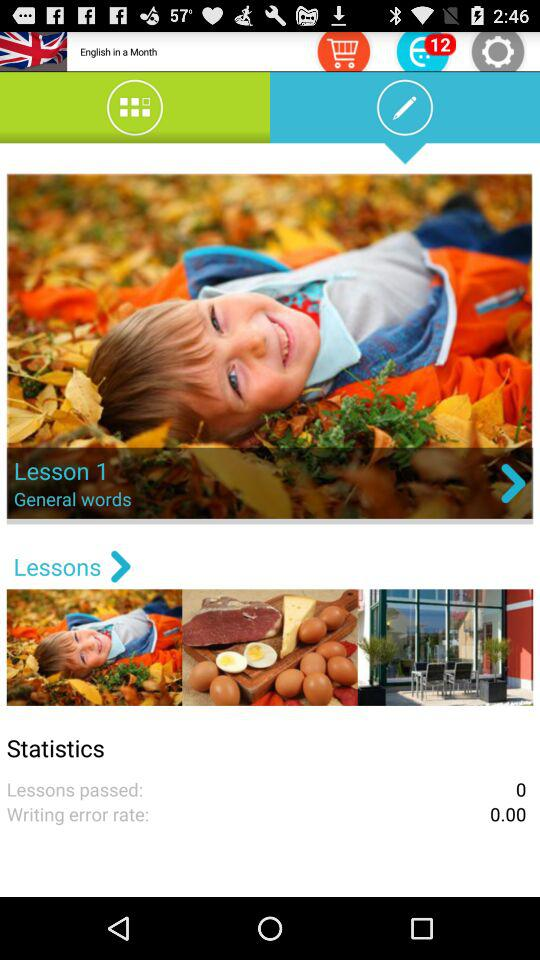What is the lesson name? The lesson name is "General words". 